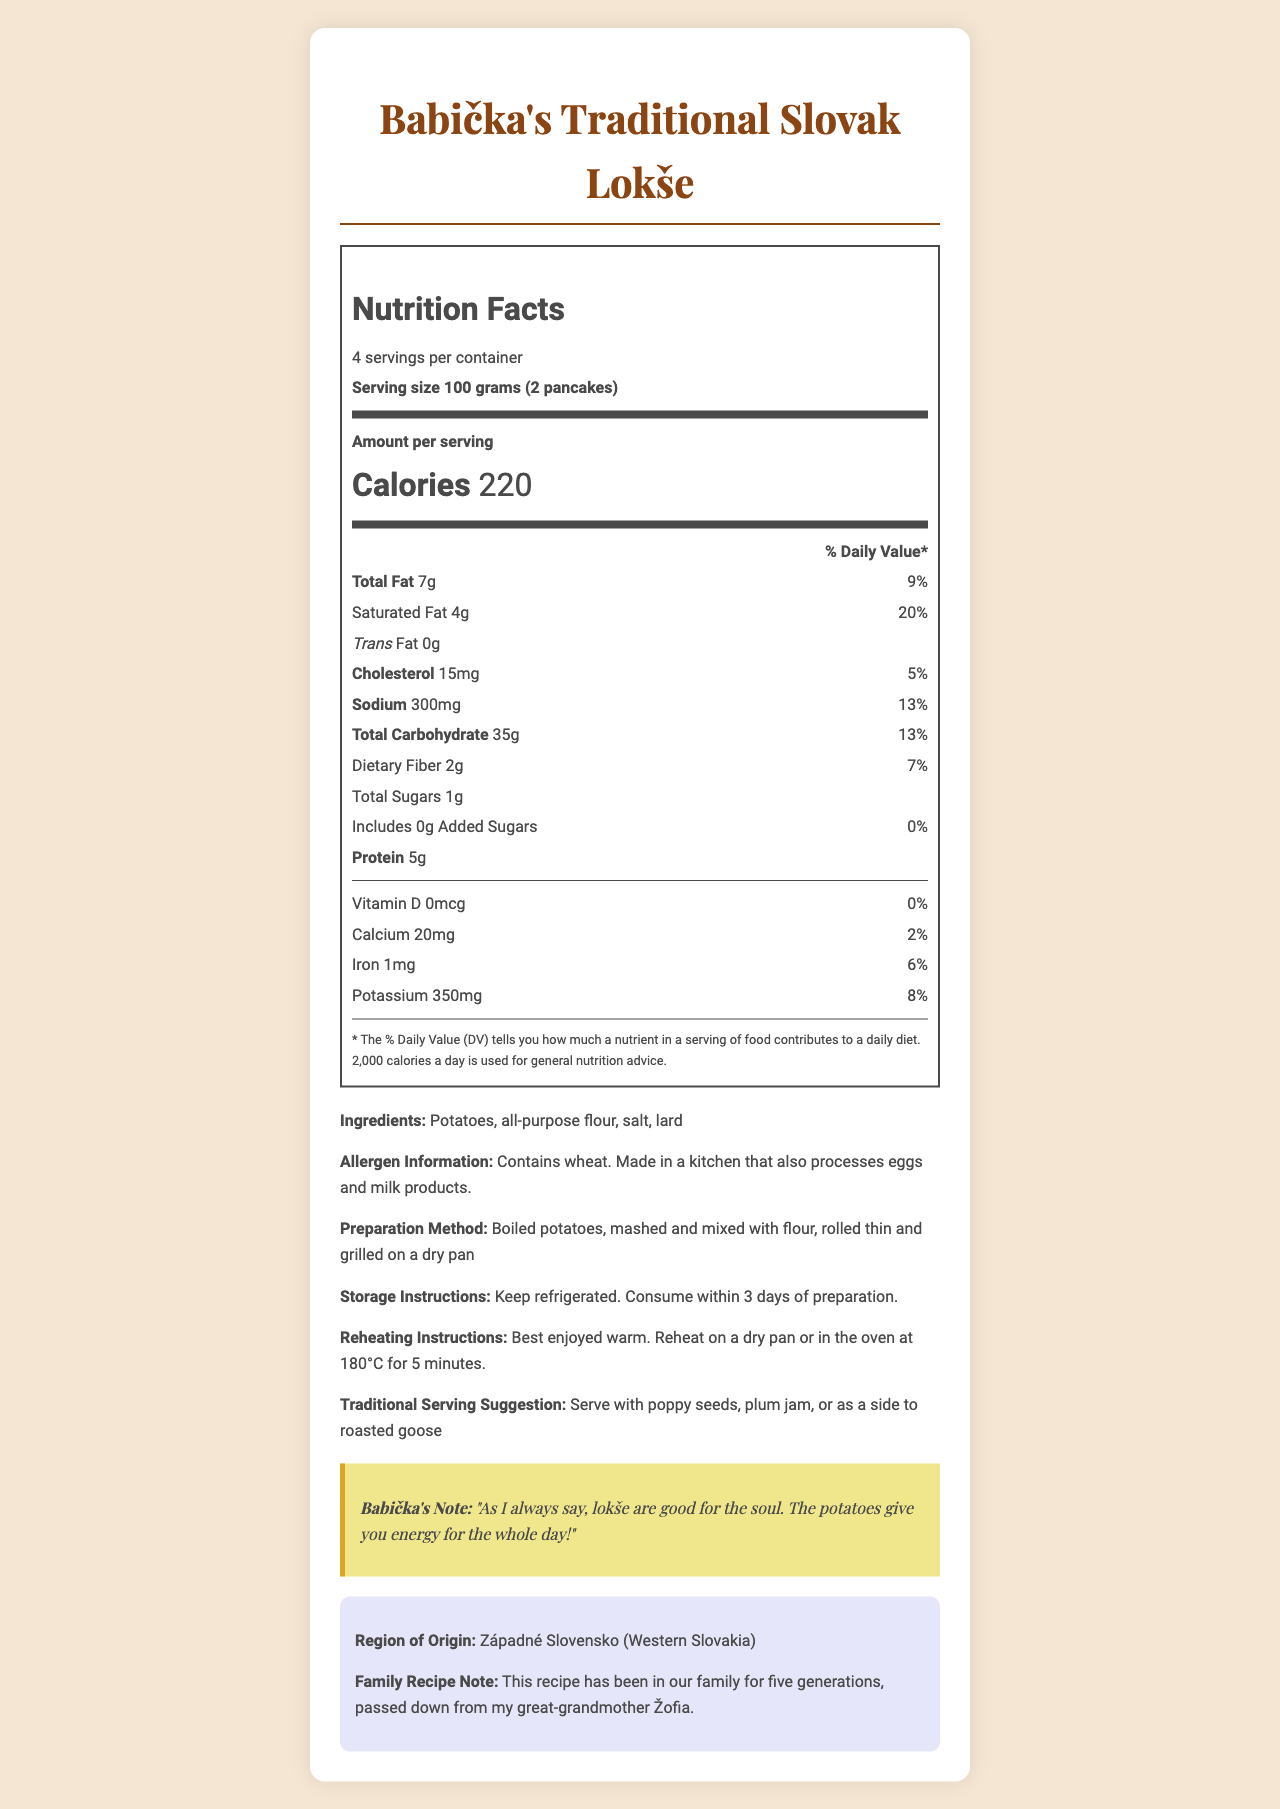what is the serving size? The serving size is clearly stated at the beginning of the Nutrition Facts section.
Answer: 100 grams (2 pancakes) how many calories are in one serving of Babička's Traditional Slovak Lokše? The Nutrition Facts label shows the calories per serving.
Answer: 220 calories how much total fat is in one serving? The total fat per serving is listed as 7 grams in the Nutrition Facts label.
Answer: 7g what is the percentage of daily value for sodium in one serving? The Nutrition Facts label displays the daily value percentage for sodium as 13%.
Answer: 13% how much dietary fiber is in each serving? The amount of dietary fiber per serving is provided in the Nutrition Facts label.
Answer: 2g does the lokše contain any trans fat? The Nutrition Facts label shows trans fat as 0g.
Answer: No how much potassium is in one serving? A. 100mg B. 200mg C. 350mg D. 500mg The Nutrition Facts label indicates that there is 350mg of potassium per serving.
Answer: C what is the amount of added sugars in one serving? A. 0g B. 1g C. 2g D. 3g The Nutrition Facts label shows added sugars as 0g.
Answer: A is there any vitamin D in the lokše? The Nutrition Facts label indicates 0mcg of vitamin D with a 0% daily value.
Answer: No summarize the main nutritional points of the document. This provides a comprehensive overview of the nutritional information in the document.
Answer: The document describes the nutrition facts for Babička's Traditional Slovak Lokše. It lists the serving size as 100 grams (2 pancakes) with 220 calories per serving. The total fat is 7 grams (9% daily value), including 4 grams of saturated fat (20% daily value) and 0 grams of trans fat. Each serving has 15mg of cholesterol (5% daily value), 300mg of sodium (13% daily value), 35 grams of total carbohydrates (13% daily value), 2 grams of dietary fiber (7% daily value), 1 gram of total sugars (with 0 grams of added sugars), 5 grams of protein, and no vitamin D. There are small amounts of calcium (20mg, 2% daily value), iron (1mg, 6% daily value), and potassium (350mg, 8% daily value). what traditional approach does the family recipe take for lokše preparation? The preparation method is described in the document under the preparation method section.
Answer: Boiled potatoes, mashed and mixed with flour, rolled thin and grilled on a dry pan is the information on how to store and reheat the lokše provided? The document includes storage instructions (keep refrigerated, consume within 3 days) and reheating instructions (reheat on a dry pan or in the oven at 180°C for 5 minutes).
Answer: Yes what is the region of origin for this recipe? The region of origin is stated in the origin information section.
Answer: Západné Slovensko (Western Slovakia) how many servings does one container have? The document states that there are 4 servings per container.
Answer: 4 servings what is the percentage of daily value for saturated fat? The Nutrition Facts label shows the saturated fat daily value as 20%.
Answer: 20% which of the following allergens are mentioned in the document? A. Peanuts B. Wheat C. Soy D. Fish The allergen information indicates that the product contains wheat.
Answer: B how much iron is provided per serving? The Nutrition Facts label lists the iron content as 1mg per serving.
Answer: 1mg what is the primary ingredient used to prepare lokše? The primary ingredient, listed first in the ingredients section, is potatoes.
Answer: Potatoes how many types of carbohydrates are listed in the document? A. One type B. Two types C. Three types D. Four types The document lists two types of carbohydrates: total carbohydrates and dietary fiber.
Answer: B what is the family recipe note indicated in the document? This note is provided under the family recipe note section.
Answer: This recipe has been in our family for five generations, passed down from my great-grandmother Žofia. how many grams of protein are there in one serving? The Nutrition Facts label states there are 5 grams of protein per serving.
Answer: 5g how many days can the lokše be stored after preparation? The storage instructions state to consume within 3 days of preparation.
Answer: 3 days can I determine the exact recipe proportions from the information provided? The document does not provide exact recipe proportions, only the preparation method and ingredients.
Answer: Cannot be determined 